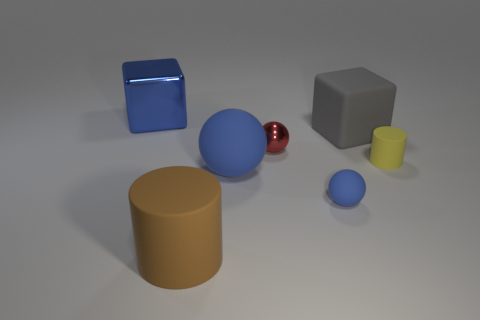Is the color of the tiny rubber sphere the same as the big sphere?
Provide a short and direct response. Yes. Is the number of red spheres to the left of the large matte cylinder greater than the number of tiny balls?
Offer a very short reply. No. There is a cylinder that is behind the big rubber cylinder; what number of tiny balls are in front of it?
Make the answer very short. 1. Is the block left of the large blue matte thing made of the same material as the tiny object behind the small yellow thing?
Offer a terse response. Yes. There is a big ball that is the same color as the big metal cube; what material is it?
Offer a very short reply. Rubber. What number of small blue objects have the same shape as the big metallic object?
Make the answer very short. 0. Does the big brown thing have the same material as the cube to the right of the red metal ball?
Make the answer very short. Yes. There is a blue sphere that is the same size as the gray thing; what material is it?
Your response must be concise. Rubber. Are there any cylinders of the same size as the matte cube?
Your answer should be very brief. Yes. What is the shape of the red thing that is the same size as the yellow matte object?
Make the answer very short. Sphere. 